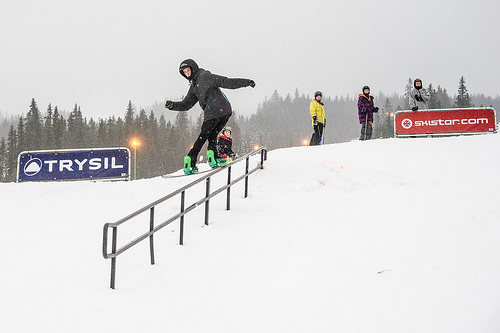Can you tell what activity the person in the foreground is engaged in? The person in the foreground appears to be snowboarding, performing a trick or maneuver on a rail. Describe the expression and body language of the people in the background. The people in the background seem to be observing the snowboarder with keen interest, possibly friends or family. They appear to be relaxed and enjoying the winter day, bundled up in bright, colorful winter gear. 